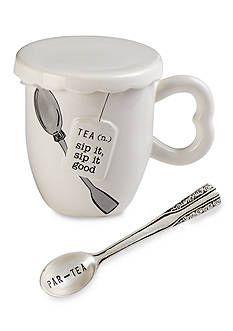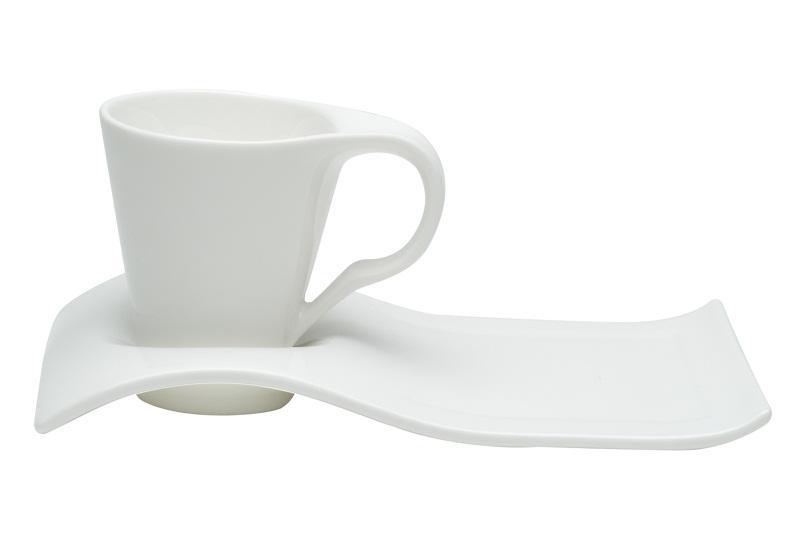The first image is the image on the left, the second image is the image on the right. Evaluate the accuracy of this statement regarding the images: "The left image depicts exactly one spoon next to one container.". Is it true? Answer yes or no. Yes. 